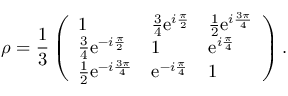Convert formula to latex. <formula><loc_0><loc_0><loc_500><loc_500>\rho = \frac { 1 } { 3 } \left ( \begin{array} { l l l } { 1 } & { \frac { 3 } { 4 } e ^ { i \frac { \pi } { 2 } } } & { \frac { 1 } { 2 } e ^ { i \frac { 3 \pi } { 4 } } } \\ { \frac { 3 } { 4 } e ^ { - i \frac { \pi } { 2 } } } & { 1 } & { e ^ { i \frac { \pi } { 4 } } } \\ { \frac { 1 } { 2 } e ^ { - i \frac { 3 \pi } { 4 } } } & { e ^ { - i \frac { \pi } { 4 } } } & { 1 } \end{array} \right ) .</formula> 